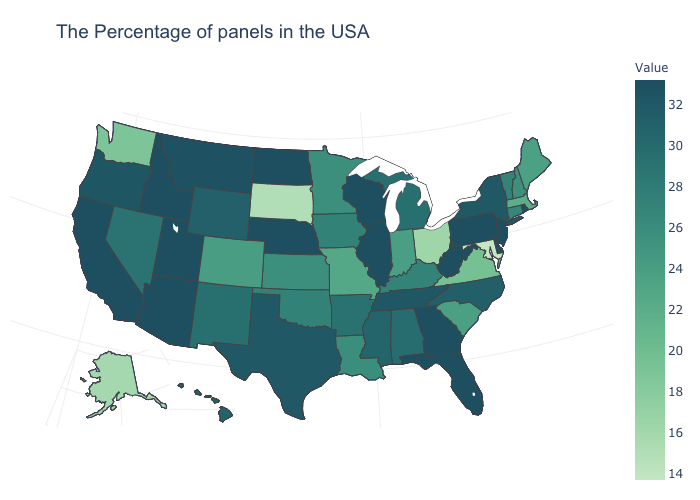Does New Mexico have the highest value in the USA?
Keep it brief. No. Which states hav the highest value in the MidWest?
Quick response, please. Wisconsin, Illinois, Nebraska, North Dakota. Among the states that border Virginia , which have the lowest value?
Answer briefly. Maryland. 